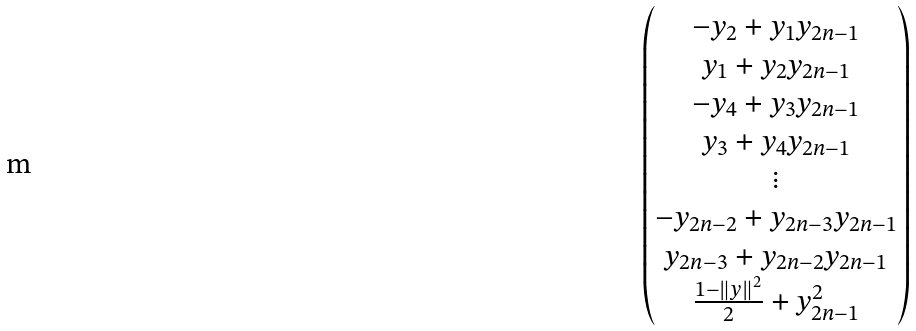<formula> <loc_0><loc_0><loc_500><loc_500>\begin{pmatrix} - y _ { 2 } + y _ { 1 } y _ { 2 n - 1 } \\ y _ { 1 } + y _ { 2 } y _ { 2 n - 1 } \\ - y _ { 4 } + y _ { 3 } y _ { 2 n - 1 } \\ y _ { 3 } + y _ { 4 } y _ { 2 n - 1 } \\ \vdots \\ - y _ { 2 n - 2 } + y _ { 2 n - 3 } y _ { 2 n - 1 } \\ y _ { 2 n - 3 } + y _ { 2 n - 2 } y _ { 2 n - 1 } \\ \frac { 1 - \left \| y \right \| ^ { 2 } } { 2 } + y _ { 2 n - 1 } ^ { 2 } \end{pmatrix}</formula> 